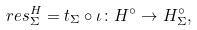<formula> <loc_0><loc_0><loc_500><loc_500>r e s ^ { H } _ { \Sigma } = t _ { \Sigma } \circ \iota \colon H ^ { \circ } \to H _ { \Sigma } ^ { \circ } ,</formula> 